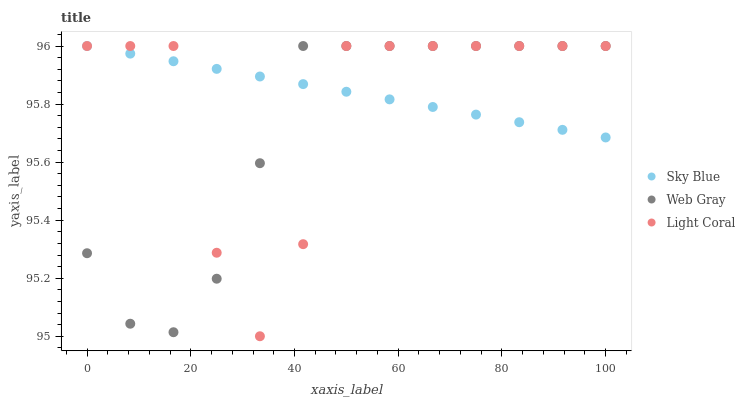Does Web Gray have the minimum area under the curve?
Answer yes or no. Yes. Does Sky Blue have the maximum area under the curve?
Answer yes or no. Yes. Does Sky Blue have the minimum area under the curve?
Answer yes or no. No. Does Web Gray have the maximum area under the curve?
Answer yes or no. No. Is Sky Blue the smoothest?
Answer yes or no. Yes. Is Light Coral the roughest?
Answer yes or no. Yes. Is Web Gray the smoothest?
Answer yes or no. No. Is Web Gray the roughest?
Answer yes or no. No. Does Light Coral have the lowest value?
Answer yes or no. Yes. Does Web Gray have the lowest value?
Answer yes or no. No. Does Web Gray have the highest value?
Answer yes or no. Yes. Does Sky Blue intersect Web Gray?
Answer yes or no. Yes. Is Sky Blue less than Web Gray?
Answer yes or no. No. Is Sky Blue greater than Web Gray?
Answer yes or no. No. 